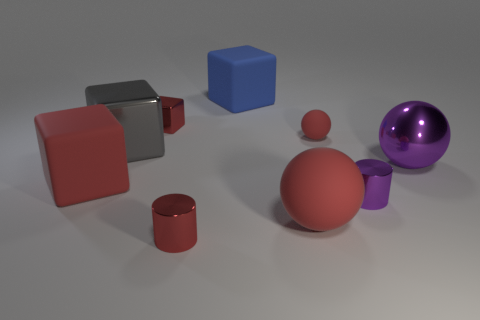What materials do the objects in the image appear to be made of? The objects in the image appear to have different materials. The red cubes and the purple cylinder have a metallic sheen, indicating they might be made of metal. The orange sphere and cylinder seem to have a matte finish, suggesting a plastic or ceramic material. Lastly, the blue cube has a consistent, matte color, which also implies it may be plastic. 